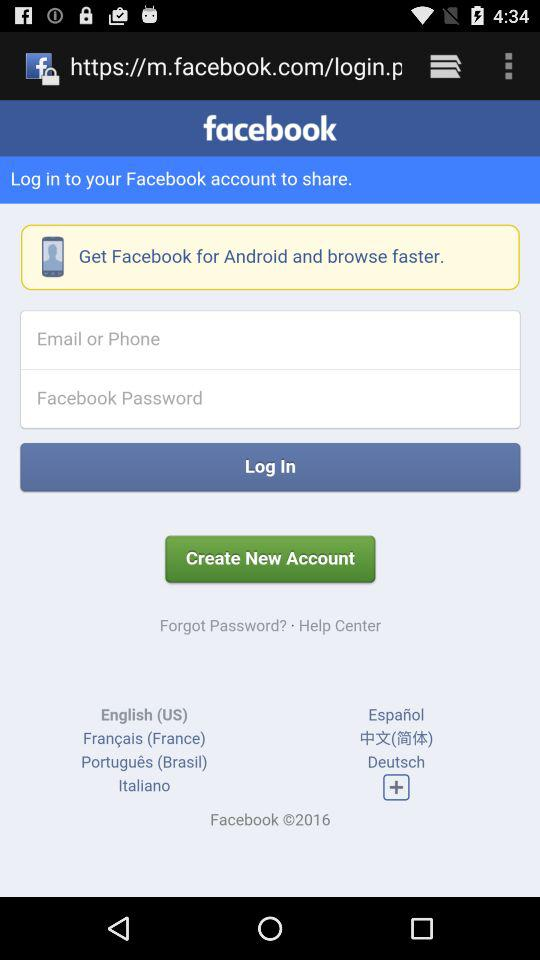What needs to be done for fast browsing? For fast browsing, get "Facebook" for Android. 